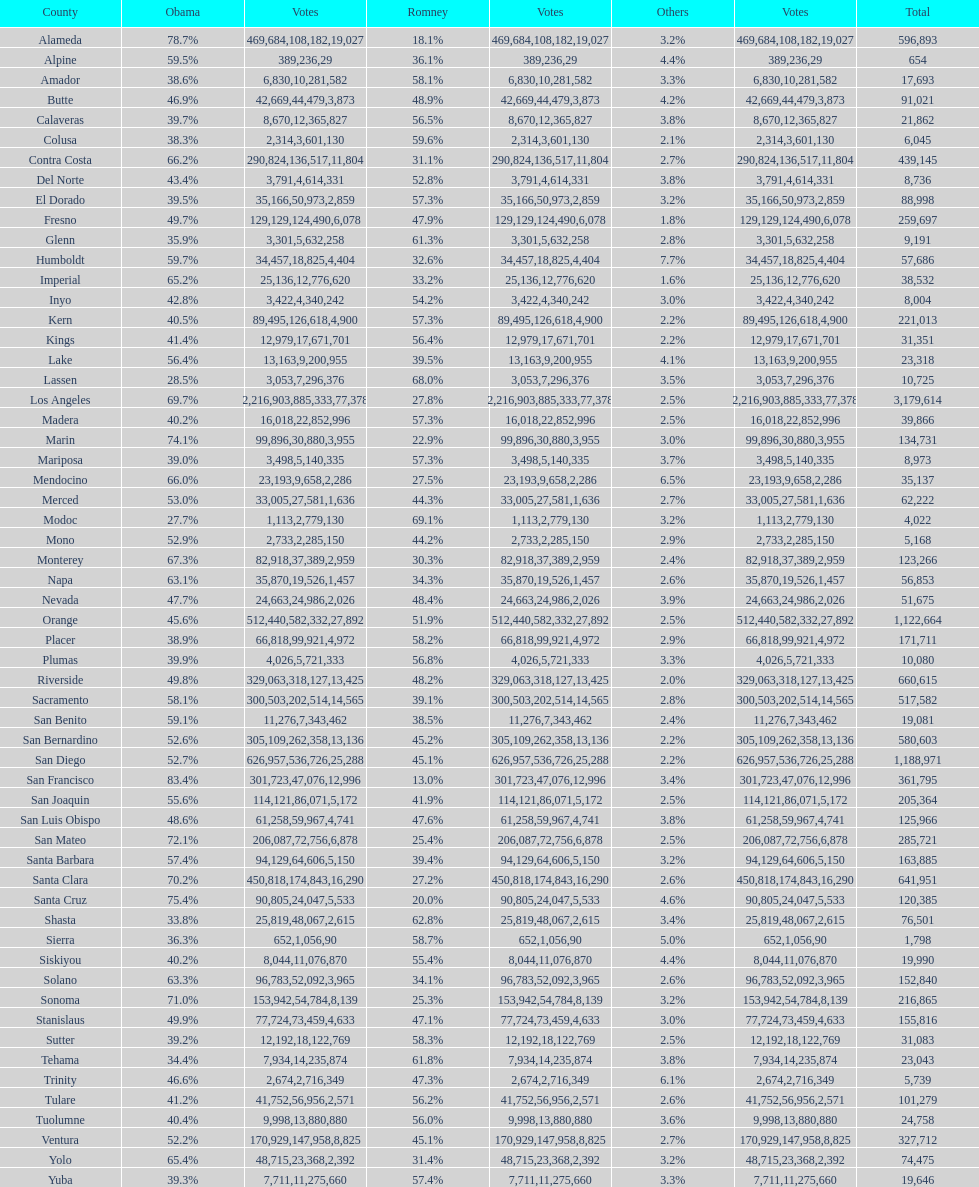Did romney earn more or less votes than obama did in alameda county? Less. Could you parse the entire table? {'header': ['County', 'Obama', 'Votes', 'Romney', 'Votes', 'Others', 'Votes', 'Total'], 'rows': [['Alameda', '78.7%', '469,684', '18.1%', '108,182', '3.2%', '19,027', '596,893'], ['Alpine', '59.5%', '389', '36.1%', '236', '4.4%', '29', '654'], ['Amador', '38.6%', '6,830', '58.1%', '10,281', '3.3%', '582', '17,693'], ['Butte', '46.9%', '42,669', '48.9%', '44,479', '4.2%', '3,873', '91,021'], ['Calaveras', '39.7%', '8,670', '56.5%', '12,365', '3.8%', '827', '21,862'], ['Colusa', '38.3%', '2,314', '59.6%', '3,601', '2.1%', '130', '6,045'], ['Contra Costa', '66.2%', '290,824', '31.1%', '136,517', '2.7%', '11,804', '439,145'], ['Del Norte', '43.4%', '3,791', '52.8%', '4,614', '3.8%', '331', '8,736'], ['El Dorado', '39.5%', '35,166', '57.3%', '50,973', '3.2%', '2,859', '88,998'], ['Fresno', '49.7%', '129,129', '47.9%', '124,490', '1.8%', '6,078', '259,697'], ['Glenn', '35.9%', '3,301', '61.3%', '5,632', '2.8%', '258', '9,191'], ['Humboldt', '59.7%', '34,457', '32.6%', '18,825', '7.7%', '4,404', '57,686'], ['Imperial', '65.2%', '25,136', '33.2%', '12,776', '1.6%', '620', '38,532'], ['Inyo', '42.8%', '3,422', '54.2%', '4,340', '3.0%', '242', '8,004'], ['Kern', '40.5%', '89,495', '57.3%', '126,618', '2.2%', '4,900', '221,013'], ['Kings', '41.4%', '12,979', '56.4%', '17,671', '2.2%', '701', '31,351'], ['Lake', '56.4%', '13,163', '39.5%', '9,200', '4.1%', '955', '23,318'], ['Lassen', '28.5%', '3,053', '68.0%', '7,296', '3.5%', '376', '10,725'], ['Los Angeles', '69.7%', '2,216,903', '27.8%', '885,333', '2.5%', '77,378', '3,179,614'], ['Madera', '40.2%', '16,018', '57.3%', '22,852', '2.5%', '996', '39,866'], ['Marin', '74.1%', '99,896', '22.9%', '30,880', '3.0%', '3,955', '134,731'], ['Mariposa', '39.0%', '3,498', '57.3%', '5,140', '3.7%', '335', '8,973'], ['Mendocino', '66.0%', '23,193', '27.5%', '9,658', '6.5%', '2,286', '35,137'], ['Merced', '53.0%', '33,005', '44.3%', '27,581', '2.7%', '1,636', '62,222'], ['Modoc', '27.7%', '1,113', '69.1%', '2,779', '3.2%', '130', '4,022'], ['Mono', '52.9%', '2,733', '44.2%', '2,285', '2.9%', '150', '5,168'], ['Monterey', '67.3%', '82,918', '30.3%', '37,389', '2.4%', '2,959', '123,266'], ['Napa', '63.1%', '35,870', '34.3%', '19,526', '2.6%', '1,457', '56,853'], ['Nevada', '47.7%', '24,663', '48.4%', '24,986', '3.9%', '2,026', '51,675'], ['Orange', '45.6%', '512,440', '51.9%', '582,332', '2.5%', '27,892', '1,122,664'], ['Placer', '38.9%', '66,818', '58.2%', '99,921', '2.9%', '4,972', '171,711'], ['Plumas', '39.9%', '4,026', '56.8%', '5,721', '3.3%', '333', '10,080'], ['Riverside', '49.8%', '329,063', '48.2%', '318,127', '2.0%', '13,425', '660,615'], ['Sacramento', '58.1%', '300,503', '39.1%', '202,514', '2.8%', '14,565', '517,582'], ['San Benito', '59.1%', '11,276', '38.5%', '7,343', '2.4%', '462', '19,081'], ['San Bernardino', '52.6%', '305,109', '45.2%', '262,358', '2.2%', '13,136', '580,603'], ['San Diego', '52.7%', '626,957', '45.1%', '536,726', '2.2%', '25,288', '1,188,971'], ['San Francisco', '83.4%', '301,723', '13.0%', '47,076', '3.4%', '12,996', '361,795'], ['San Joaquin', '55.6%', '114,121', '41.9%', '86,071', '2.5%', '5,172', '205,364'], ['San Luis Obispo', '48.6%', '61,258', '47.6%', '59,967', '3.8%', '4,741', '125,966'], ['San Mateo', '72.1%', '206,087', '25.4%', '72,756', '2.5%', '6,878', '285,721'], ['Santa Barbara', '57.4%', '94,129', '39.4%', '64,606', '3.2%', '5,150', '163,885'], ['Santa Clara', '70.2%', '450,818', '27.2%', '174,843', '2.6%', '16,290', '641,951'], ['Santa Cruz', '75.4%', '90,805', '20.0%', '24,047', '4.6%', '5,533', '120,385'], ['Shasta', '33.8%', '25,819', '62.8%', '48,067', '3.4%', '2,615', '76,501'], ['Sierra', '36.3%', '652', '58.7%', '1,056', '5.0%', '90', '1,798'], ['Siskiyou', '40.2%', '8,044', '55.4%', '11,076', '4.4%', '870', '19,990'], ['Solano', '63.3%', '96,783', '34.1%', '52,092', '2.6%', '3,965', '152,840'], ['Sonoma', '71.0%', '153,942', '25.3%', '54,784', '3.2%', '8,139', '216,865'], ['Stanislaus', '49.9%', '77,724', '47.1%', '73,459', '3.0%', '4,633', '155,816'], ['Sutter', '39.2%', '12,192', '58.3%', '18,122', '2.5%', '769', '31,083'], ['Tehama', '34.4%', '7,934', '61.8%', '14,235', '3.8%', '874', '23,043'], ['Trinity', '46.6%', '2,674', '47.3%', '2,716', '6.1%', '349', '5,739'], ['Tulare', '41.2%', '41,752', '56.2%', '56,956', '2.6%', '2,571', '101,279'], ['Tuolumne', '40.4%', '9,998', '56.0%', '13,880', '3.6%', '880', '24,758'], ['Ventura', '52.2%', '170,929', '45.1%', '147,958', '2.7%', '8,825', '327,712'], ['Yolo', '65.4%', '48,715', '31.4%', '23,368', '3.2%', '2,392', '74,475'], ['Yuba', '39.3%', '7,711', '57.4%', '11,275', '3.3%', '660', '19,646']]} 